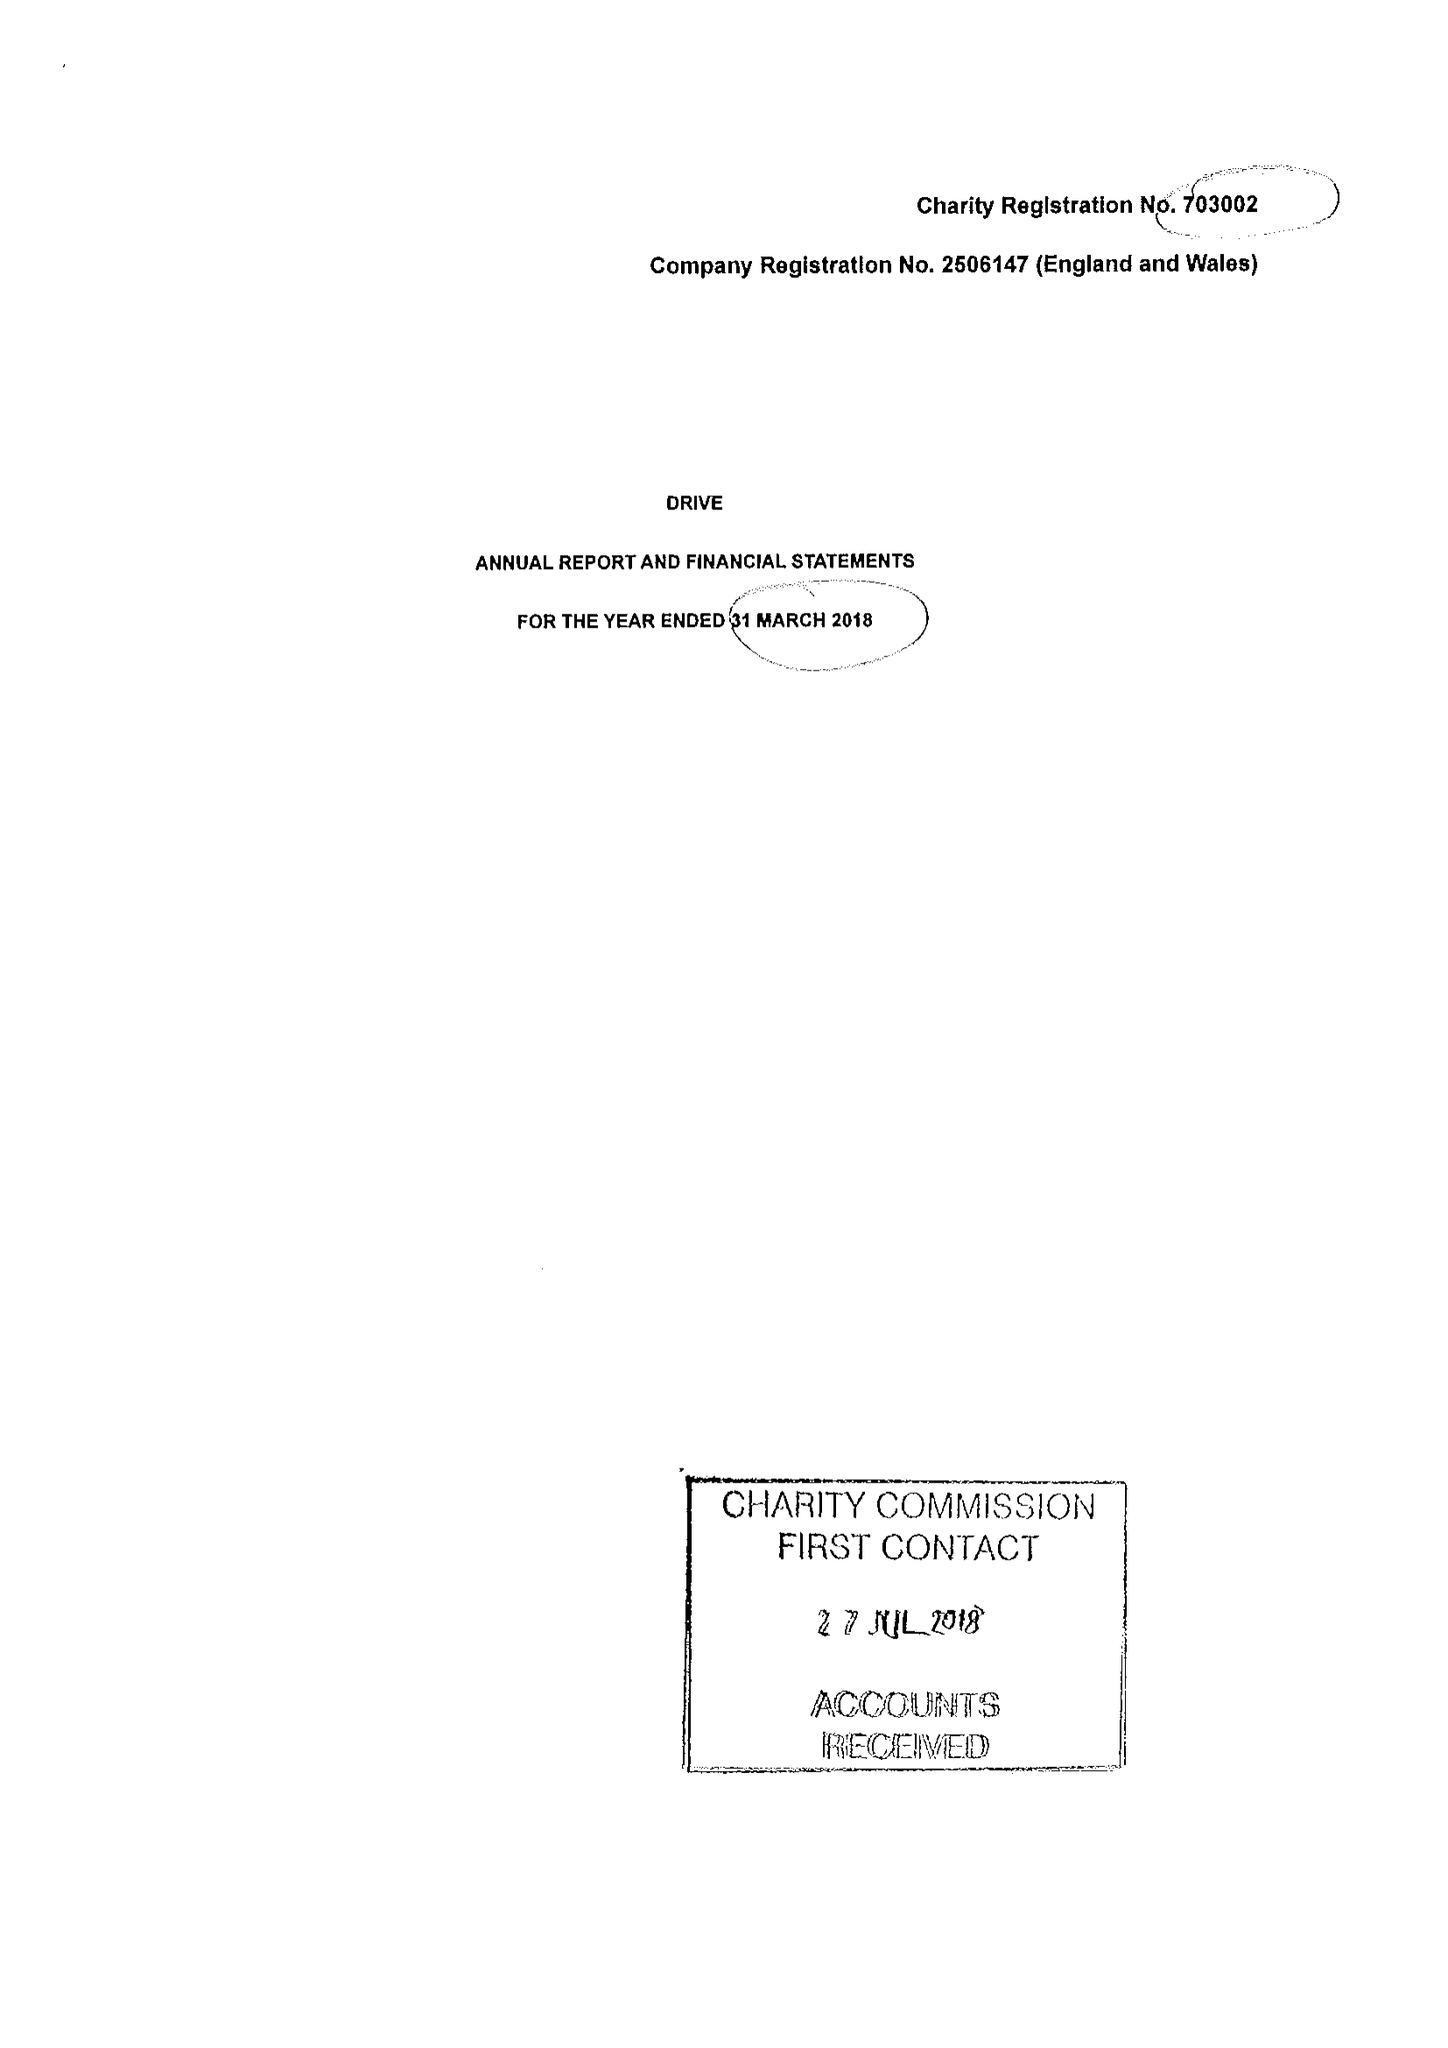What is the value for the address__street_line?
Answer the question using a single word or phrase. CEFN COED 